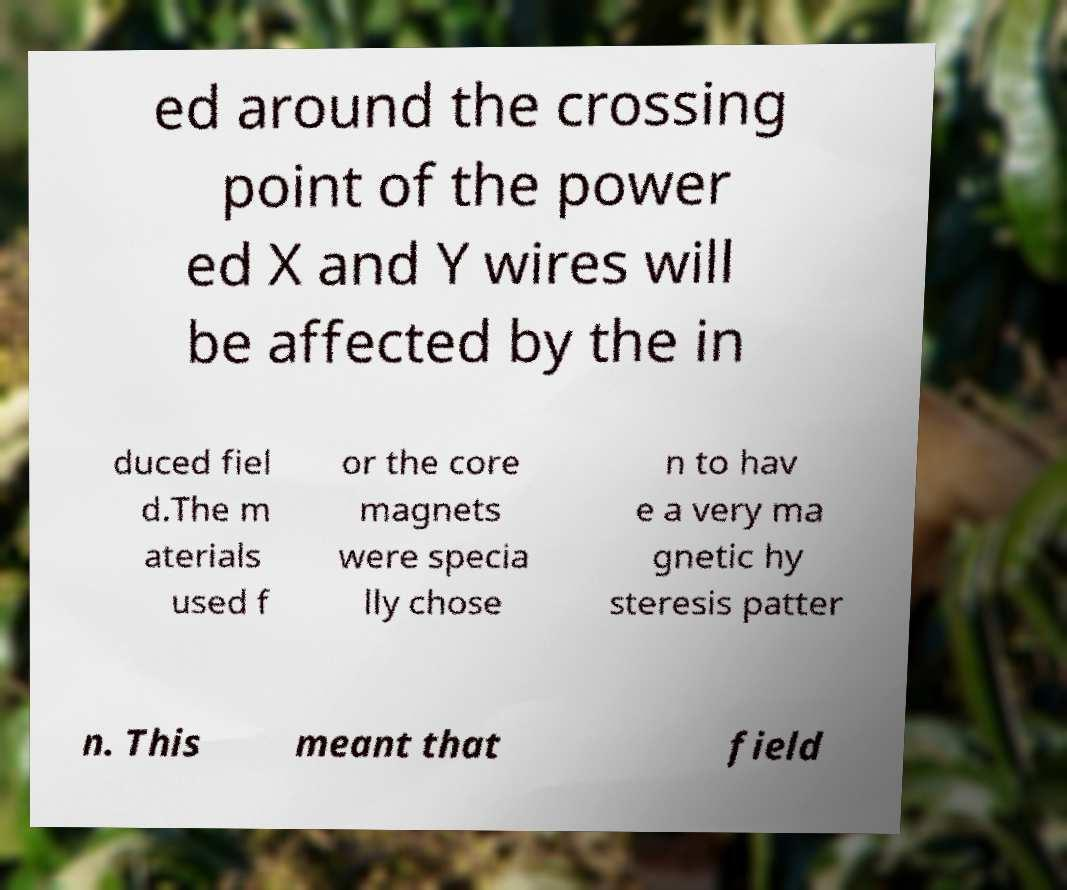What messages or text are displayed in this image? I need them in a readable, typed format. ed around the crossing point of the power ed X and Y wires will be affected by the in duced fiel d.The m aterials used f or the core magnets were specia lly chose n to hav e a very ma gnetic hy steresis patter n. This meant that field 